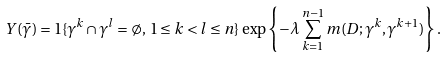<formula> <loc_0><loc_0><loc_500><loc_500>Y ( { \bar { \gamma } } ) = 1 \{ \gamma ^ { k } \cap \gamma ^ { l } = \emptyset , \, 1 \leq k < l \leq n \} \, \exp \left \{ - \lambda \sum _ { k = 1 } ^ { n - 1 } m ( D ; \gamma ^ { k } , \gamma ^ { k + 1 } ) \right \} .</formula> 